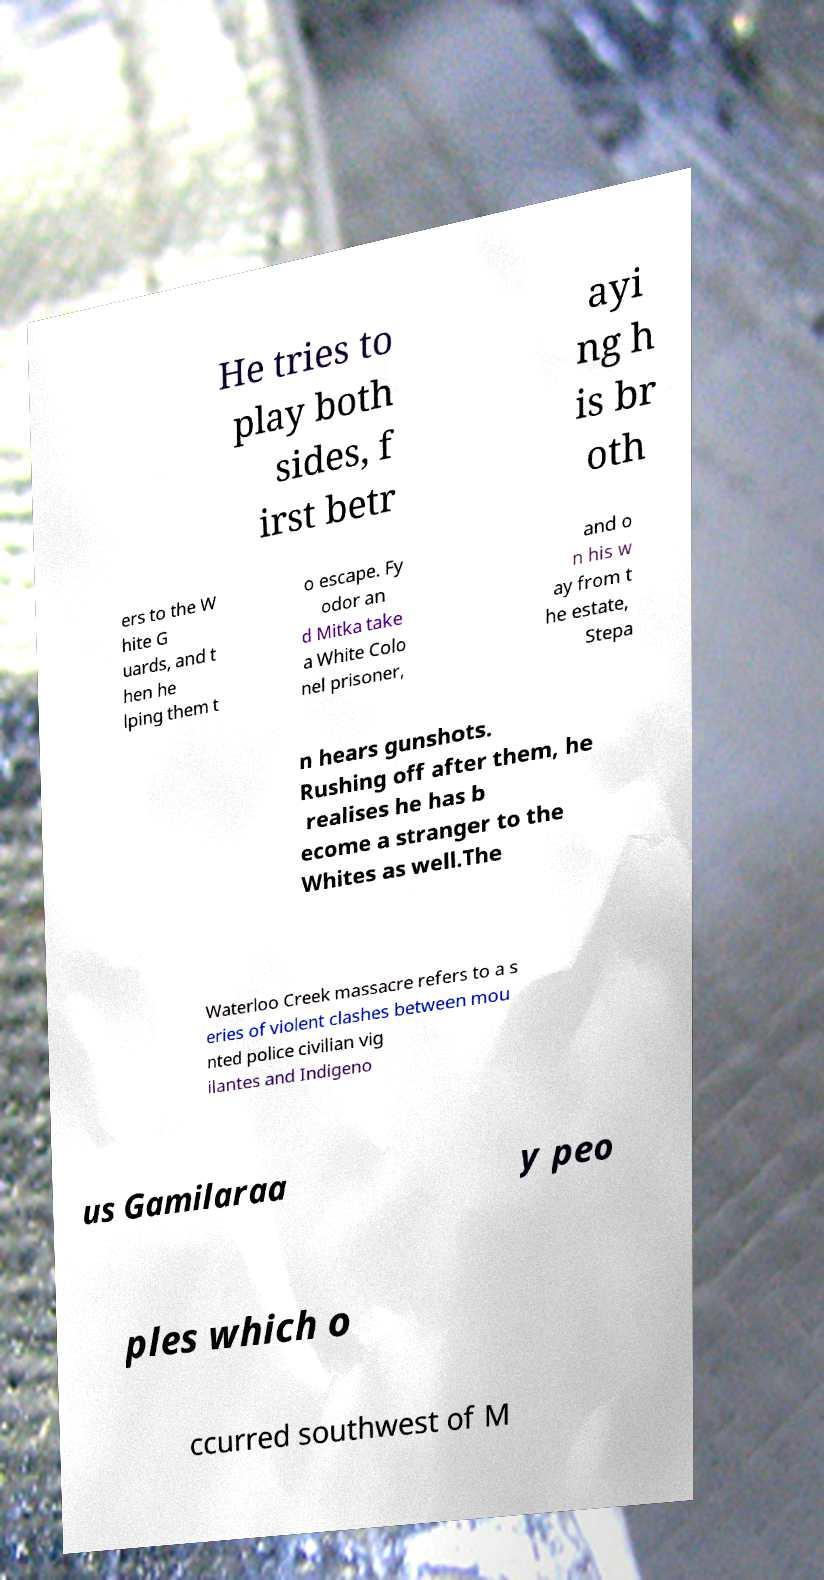What messages or text are displayed in this image? I need them in a readable, typed format. He tries to play both sides, f irst betr ayi ng h is br oth ers to the W hite G uards, and t hen he lping them t o escape. Fy odor an d Mitka take a White Colo nel prisoner, and o n his w ay from t he estate, Stepa n hears gunshots. Rushing off after them, he realises he has b ecome a stranger to the Whites as well.The Waterloo Creek massacre refers to a s eries of violent clashes between mou nted police civilian vig ilantes and Indigeno us Gamilaraa y peo ples which o ccurred southwest of M 